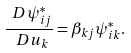<formula> <loc_0><loc_0><loc_500><loc_500>\frac { \ D \psi _ { i j } ^ { * } } { \ D u _ { k } } = \beta _ { k j } \psi _ { i k } ^ { * } .</formula> 